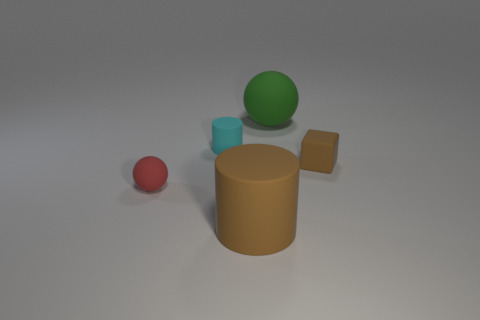There is a cylinder that is the same color as the small cube; what is its size?
Provide a succinct answer. Large. Is the color of the tiny rubber object that is on the right side of the green rubber sphere the same as the large cylinder?
Ensure brevity in your answer.  Yes. What number of other things are there of the same color as the rubber cube?
Offer a very short reply. 1. What is the green object made of?
Give a very brief answer. Rubber. What number of things are either big things in front of the small cyan matte object or big brown cylinders?
Ensure brevity in your answer.  1. Is the rubber cube the same color as the big cylinder?
Make the answer very short. Yes. Is there a cylinder of the same size as the red object?
Make the answer very short. Yes. What number of tiny things are both on the left side of the large cylinder and on the right side of the red rubber object?
Offer a very short reply. 1. How many green matte things are to the right of the small red sphere?
Your answer should be very brief. 1. Is there another rubber thing of the same shape as the tiny cyan rubber object?
Ensure brevity in your answer.  Yes. 